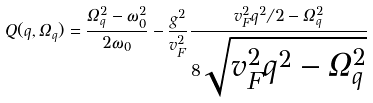<formula> <loc_0><loc_0><loc_500><loc_500>Q ( { q } , \Omega _ { q } ) = \frac { \Omega _ { q } ^ { 2 } - \omega _ { 0 } ^ { 2 } } { 2 \omega _ { 0 } } - \frac { g ^ { 2 } } { v _ { F } ^ { 2 } } \frac { v _ { F } ^ { 2 } { q } ^ { 2 } / 2 - \Omega _ { q } ^ { 2 } } { 8 \sqrt { v _ { F } ^ { 2 } { q } ^ { 2 } - \Omega _ { q } ^ { 2 } } }</formula> 